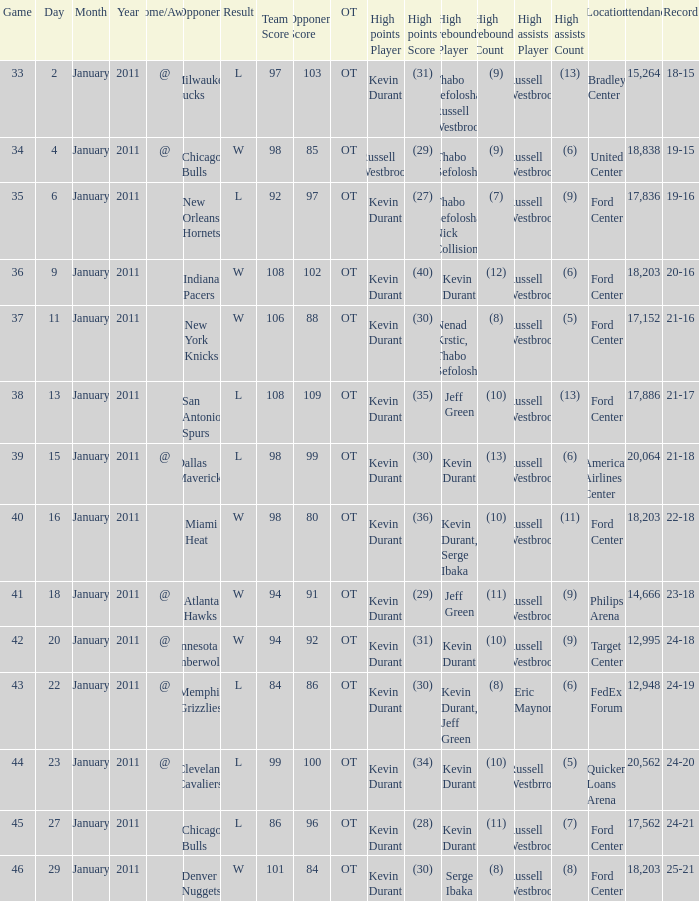Name the team for january 4 @ Chicago Bulls. 